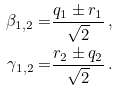Convert formula to latex. <formula><loc_0><loc_0><loc_500><loc_500>\beta _ { 1 , 2 } = & \frac { q _ { 1 } \pm r _ { 1 } } { \sqrt { 2 } } \, , \\ \gamma _ { 1 , 2 } = & \frac { r _ { 2 } \pm q _ { 2 } } { \sqrt { 2 } } \, .</formula> 